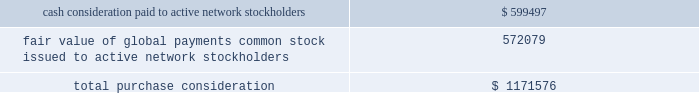Organizations evaluate whether transactions should be accounted for as acquisitions ( or disposals ) of assets or businesses , with the expectation that fewer will qualify as acquisitions ( or disposals ) of businesses .
The asu became effective for us on january 1 , 2018 .
These amendments will be applied prospectively from the date of adoption .
The effect of asu 2017-01 will be dependent upon the nature of future acquisitions or dispositions that we make , if any .
In october 2016 , the fasb issued asu 2016-16 , 201cincome taxes ( topic 740 ) : intra-entity transfers of assets other than inventory . 201d the amendments in this update state that an entity should recognize the income tax consequences of an intra-entity transfer of an asset other than inventory , such as intellectual property and property and equipment , when the transfer occurs .
We will adopt asu 2016-16 effective january 1 , 2018 with no expected effect on our consolidated financial statements .
In june 2016 , the fasb issued asu 2016-13 , 201cfinancial instruments - credit losses ( topic 326 ) : measurement of credit losses on financial instruments . 201d the amendments in this update change how companies measure and recognize credit impairment for many financial assets .
The new expected credit loss model will require companies to immediately recognize an estimate of credit losses expected to occur over the remaining life of the financial assets ( including trade receivables ) that are in the scope of the update .
The update also made amendments to the current impairment model for held-to-maturity and available-for-sale debt securities and certain guarantees .
The guidance will become effective for us on january 1 , 2020 .
Early adoption is permitted for periods beginning on or after january 1 , 2019 .
We are evaluating the effect of asu 2016-13 on our consolidated financial statements .
In january 2016 , the fasb issued asu 2016-01 , 201cfinancial instruments - overall ( subtopic 825-10 ) : recognition and measurement of financial assets and financial liabilities . 201d the amendments in this update address certain aspects of recognition , measurement , presentation and disclosure of financial instruments .
The amendments in this update supersede the guidance to classify equity securities with readily determinable fair values into different categories ( that is , trading or available-for-sale ) and require equity securities ( including other ownership interests , such as partnerships , unincorporated joint ventures and limited liability companies ) to be measured at fair value with changes in the fair value recognized through earnings .
Equity investments that are accounted for under the equity method of accounting or result in consolidation of an investee are not included within the scope of this update .
The amendments allow equity investments that do not have readily determinable fair values to be remeasured at fair value either upon the occurrence of an observable price change or upon identification of an impairment .
The amendments also require enhanced disclosures about those investments .
We will adopt asu 2016-01 effective january 1 , 2018 with no expected effect on our consolidated financial statements .
Note 2 2014 acquisitions active network we acquired the communities and sports divisions of athlaction topco , llc ( 201cactive network 201d ) on september 1 , 2017 , for total purchase consideration of $ 1.2 billion .
Active network delivers cloud-based enterprise software , including payment technology solutions , to event organizers in the communities and health and fitness markets .
This acquisition aligns with our technology-enabled , software driven strategy and adds an enterprise software business operating in two additional vertical markets that we believe offer attractive growth fundamentals .
The table summarizes the cash and non-cash components of the consideration transferred on september 1 , 2017 ( in thousands ) : .
We funded the cash portion of the total purchase consideration primarily by drawing on our revolving credit facility ( described in 201cnote 7 2014 long-term debt and lines of credit 201d ) .
The acquisition-date fair value of 72 2013 global payments inc .
| 2017 form 10-k annual report .
What portion of the total purchase consideration is paid in cash? 
Computations: (599497 / 1171576)
Answer: 0.5117. 